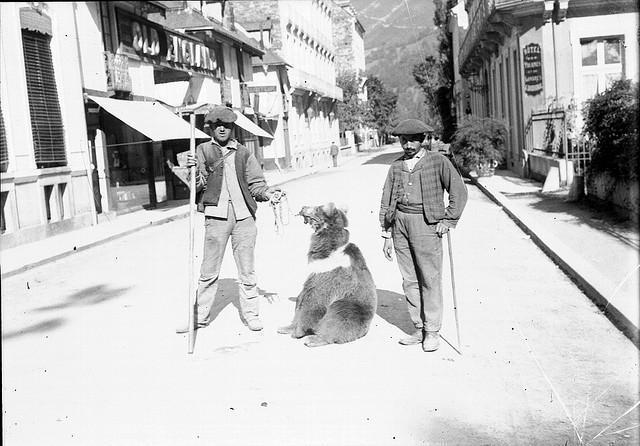How many people can you see?
Give a very brief answer. 2. How many knives are on the wall?
Give a very brief answer. 0. 